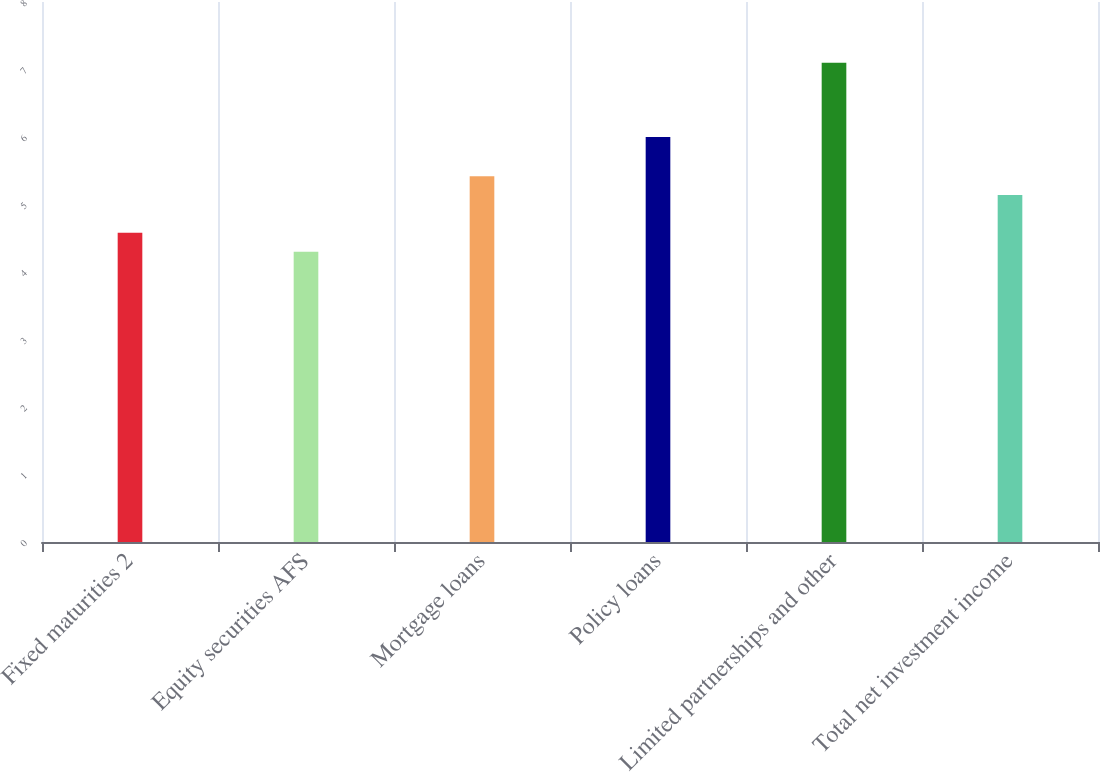Convert chart. <chart><loc_0><loc_0><loc_500><loc_500><bar_chart><fcel>Fixed maturities 2<fcel>Equity securities AFS<fcel>Mortgage loans<fcel>Policy loans<fcel>Limited partnerships and other<fcel>Total net investment income<nl><fcel>4.58<fcel>4.3<fcel>5.42<fcel>6<fcel>7.1<fcel>5.14<nl></chart> 